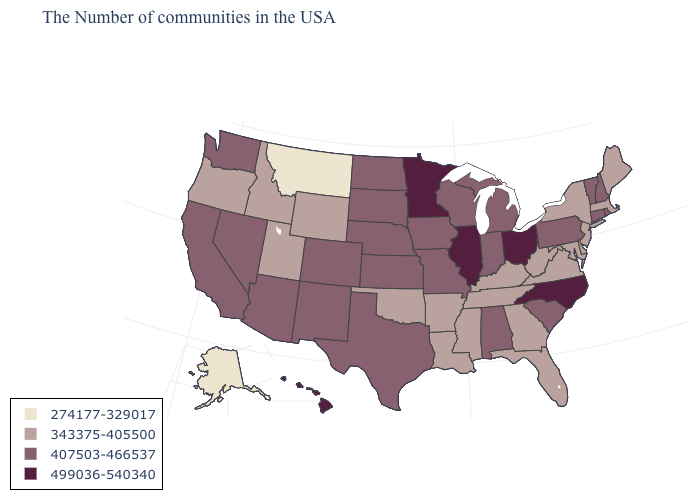What is the highest value in the Northeast ?
Answer briefly. 407503-466537. Is the legend a continuous bar?
Keep it brief. No. What is the value of Louisiana?
Quick response, please. 343375-405500. Which states have the lowest value in the South?
Concise answer only. Delaware, Maryland, Virginia, West Virginia, Florida, Georgia, Kentucky, Tennessee, Mississippi, Louisiana, Arkansas, Oklahoma. Does the map have missing data?
Concise answer only. No. What is the highest value in the Northeast ?
Give a very brief answer. 407503-466537. How many symbols are there in the legend?
Be succinct. 4. How many symbols are there in the legend?
Keep it brief. 4. What is the value of Delaware?
Be succinct. 343375-405500. Does Kentucky have the highest value in the USA?
Answer briefly. No. Does Missouri have the highest value in the MidWest?
Keep it brief. No. What is the value of Wyoming?
Short answer required. 343375-405500. Does Delaware have a higher value than Nebraska?
Write a very short answer. No. Name the states that have a value in the range 499036-540340?
Keep it brief. North Carolina, Ohio, Illinois, Minnesota, Hawaii. What is the highest value in the Northeast ?
Concise answer only. 407503-466537. 